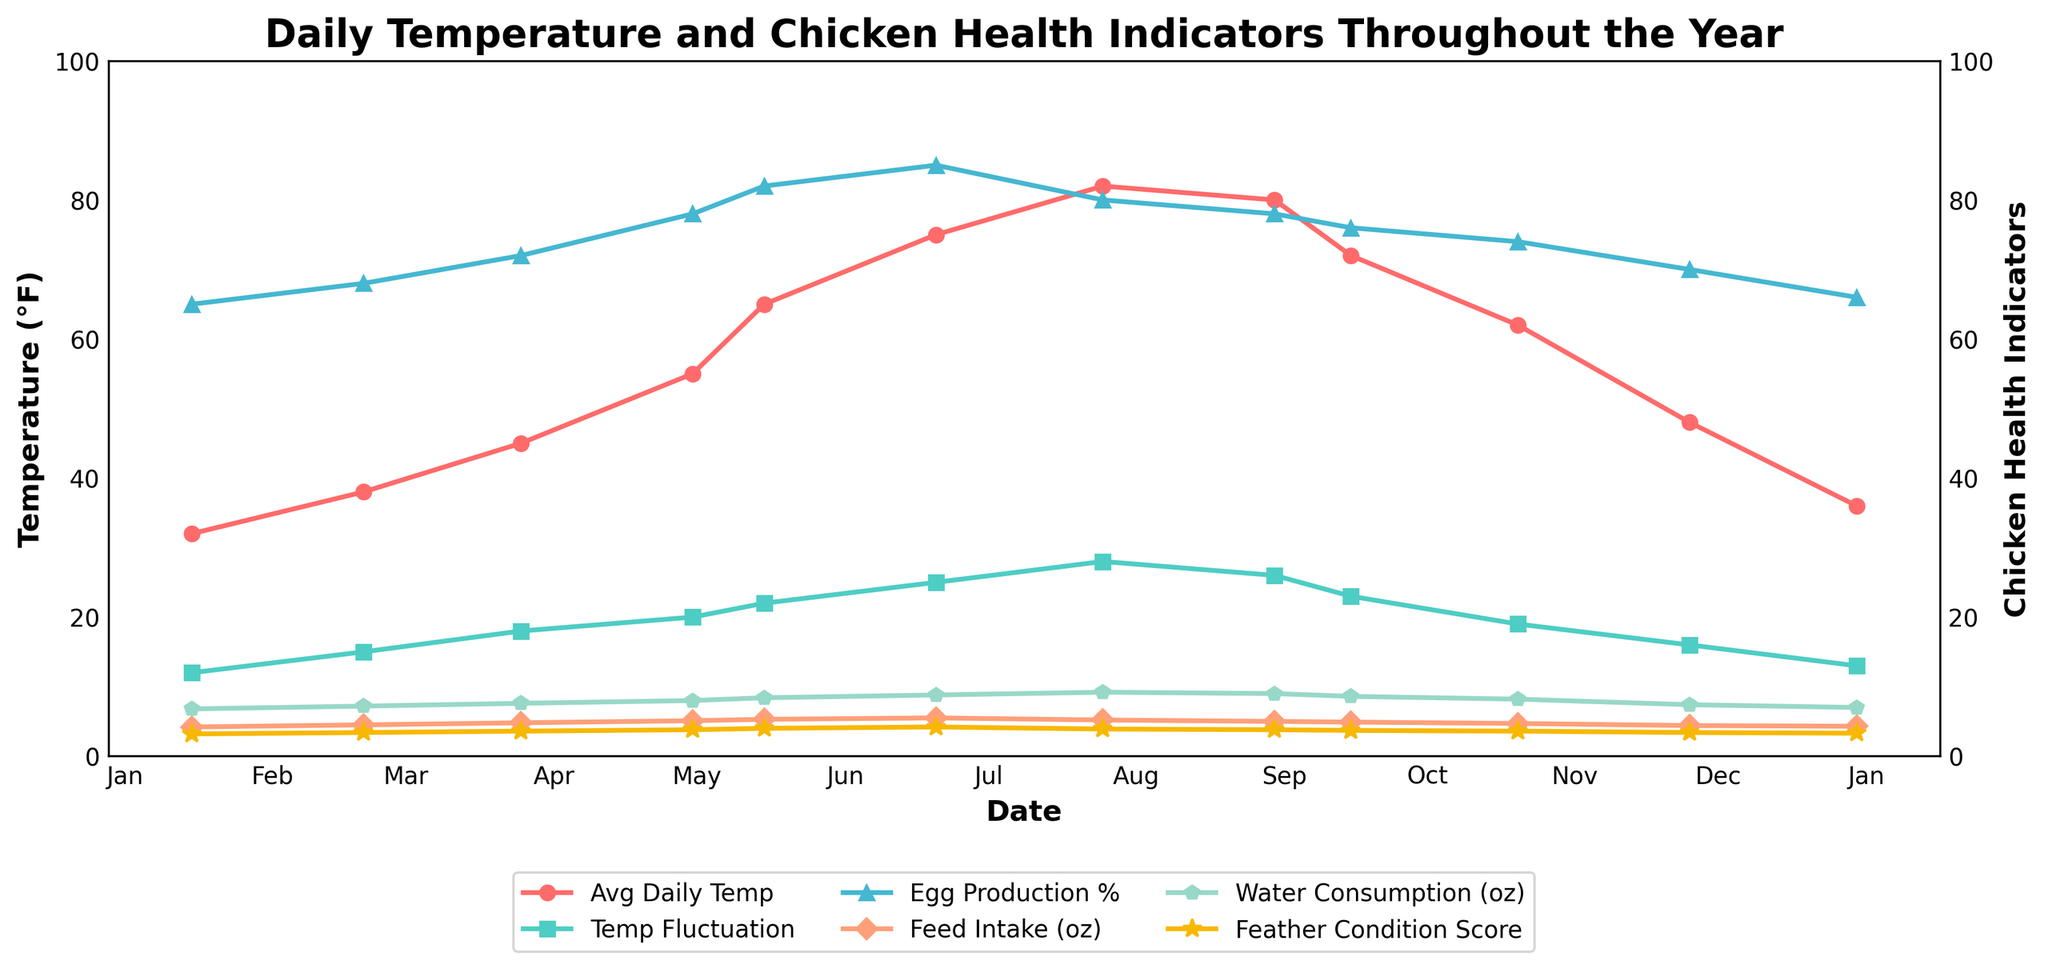What's the average temperature throughout the year? To find the average temperature, sum the average daily temperatures for each month and divide by the number of months. Total temperature: 32 + 38 + 45 + 55 + 65 + 75 + 82 + 80 + 72 + 62 + 48 + 36 = 690. Divide 690 by 12 (months) = 57.5
Answer: 57.5°F In which month does the highest egg production percentage occur? Check the line for 'Egg Production %' and identify the month with the highest value. The peak value occurs in June (85%).
Answer: June Which two months have the smallest and largest temperature fluctuations? Look at the line for 'Temp Fluctuation' and find the minimum and maximum values. January has the smallest fluctuation (12°F), and July has the largest fluctuation (28°F).
Answer: January (smallest) and July (largest) How does egg production in July compare to June? Look at the 'Egg Production %' lines for June and July. In June, it's 85%, and in July, it's 80%. Compare the two values.
Answer: Egg production decreases by 5% What is the trend in feather condition score as average daily temperature increases? Observe how the 'Feather Condition Score' changes aligned with the 'Avg Daily Temp'. As the temperature increases from January to June, the Feather Condition Score improves, peaking in June (4.2) before slightly decreasing again.
Answer: Feather condition improves with rising temperature up to June What is the feed intake in ounces during the highest average daily temperature month? Identify the month with the highest average daily temperature (July, 82°F) and find the corresponding 'Feed Intake' value.
Answer: 5.2 oz During which month is water consumption the highest? Look at the 'Water Consumption' line and find the peak value. The highest water consumption is in July (9.2 oz).
Answer: July Which months have a feather condition score above 4? Identify the months where 'Feather Condition Score' is above 4 by looking at the respective line. Only June (4.2).
Answer: June What is the range of 'Avg Daily Temp' over the year? Subtract the lowest temperature (January, 32°F) from the highest temperature (July, 82°F). 82 - 32 = 50
Answer: 50°F Is the trend of water consumption similar to the trend of average daily temperature? Compare the trends of both lines. They both increase from January, peak in July, and then decrease again, displaying a similar pattern.
Answer: Yes 